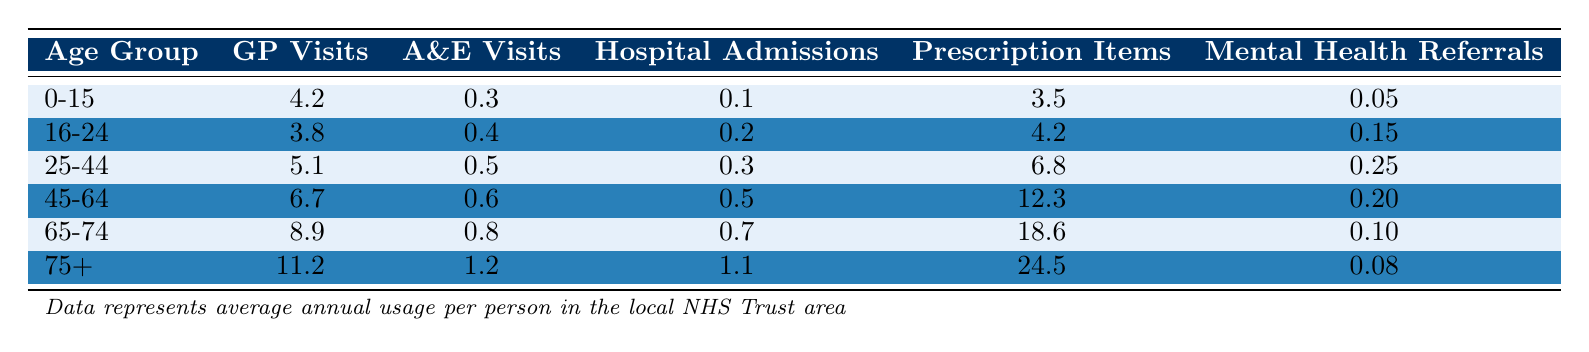What is the average number of GP visits for the age group 75+? The table shows that the average number of GP visits for the 75+ age group is listed under the "GP Visits" column. For the 75+ age group, this value is 11.2.
Answer: 11.2 Which age group has the highest number of A&E visits? By examining the "A&E Visits" column, I can see that the age group 75+ has the highest number at 1.2 visits.
Answer: 75+ What is the total number of Prescription Items for the age group 45-64? Looking at the "Prescription Items" column, the age group 45-64 has a value of 12.3, which represents the total number of prescription items for that group.
Answer: 12.3 Are there more Hospital Admissions for the age group 65-74 or 75+? The values from the "Hospital Admissions" column for 65-74 and 75+ are 0.7 and 1.1, respectively. Since 1.1 is greater than 0.7, the 75+ group has more admissions.
Answer: Yes What is the difference in GP visits between the age groups 25-44 and 45-64? The GP visits for 25-44 is 5.1, and for 45-64 it is 6.7. The difference is calculated by subtracting the smaller number from the larger number: 6.7 - 5.1 = 1.6.
Answer: 1.6 How many total Mental Health Referrals are there across all age groups? I will sum the values in the "Mental Health Referrals" column: 0.05 + 0.15 + 0.25 + 0.20 + 0.10 + 0.08 = 0.83.
Answer: 0.83 Which age group has the highest usage of Hospital Admissions? The "Hospital Admissions" column indicates that the 75+ age group, with a value of 1.1, has the highest usage among all groups.
Answer: 75+ Is the average number of A&E visits for those aged 45-64 greater than that of the 0-15 age group? The A&E visits are 0.6 for 45-64 and 0.3 for 0-15. Since 0.6 is greater than 0.3, the answer is affirmative.
Answer: Yes What is the average number of GP visits for the age groups 16-24 and 25-44 combined? First, I find the GP visits for 16-24 (3.8) and 25-44 (5.1), then calculate the average: (3.8 + 5.1) / 2 = 4.45.
Answer: 4.45 Which age group has the least number of Mental Health Referrals? Checking the "Mental Health Referrals" column, the age group 75+ has the least at 0.08 referrals.
Answer: 75+ What's the total number of GP visits for all the age groups combined? Summing the GP visits from all age groups: 4.2 + 3.8 + 5.1 + 6.7 + 8.9 + 11.2 = 39.9.
Answer: 39.9 